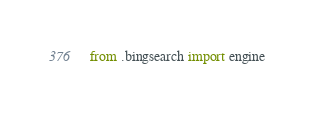<code> <loc_0><loc_0><loc_500><loc_500><_Python_>from .bingsearch import engine</code> 